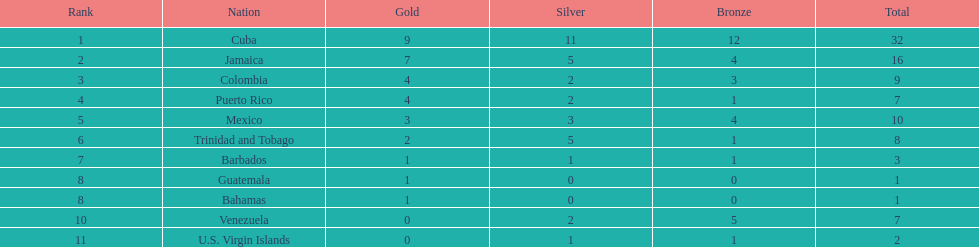In terms of medals, what distinguishes cuba from mexico? 22. 